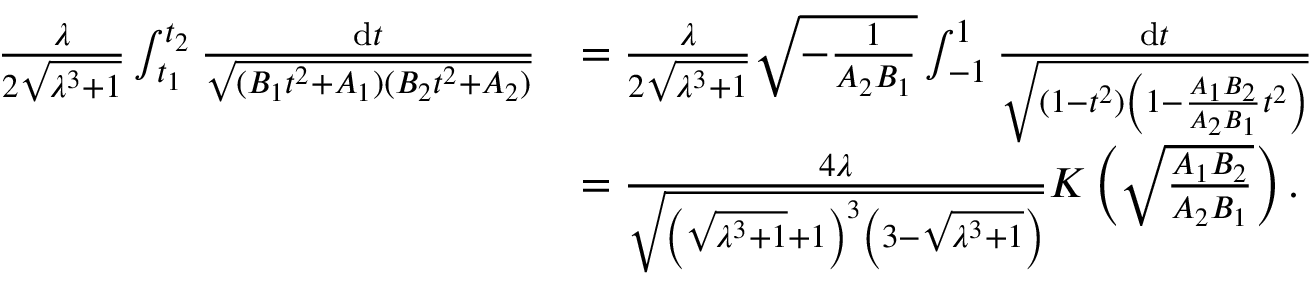Convert formula to latex. <formula><loc_0><loc_0><loc_500><loc_500>\begin{array} { r l } { \frac { \lambda } { 2 \sqrt { \lambda ^ { 3 } + 1 } } \int _ { t _ { 1 } } ^ { t _ { 2 } } \frac { \mathrm d t } { \sqrt { ( B _ { 1 } t ^ { 2 } + A _ { 1 } ) ( B _ { 2 } t ^ { 2 } + A _ { 2 } ) } } } & { = \frac { \lambda } { 2 \sqrt { \lambda ^ { 3 } + 1 } } \sqrt { - \frac { 1 } { A _ { 2 } B _ { 1 } } } \int _ { - 1 } ^ { 1 } \frac { \mathrm d t } { \sqrt { ( 1 - t ^ { 2 } ) \left ( 1 - \frac { A _ { 1 } B _ { 2 } } { A _ { 2 } B _ { 1 } } t ^ { 2 } \right ) } } } \\ & { = \frac { 4 \lambda } { \sqrt { \left ( \sqrt { \lambda ^ { 3 } + 1 } + 1 \right ) ^ { 3 } \left ( 3 - \sqrt { \lambda ^ { 3 } + 1 } \right ) } } K \left ( \sqrt { \frac { A _ { 1 } B _ { 2 } } { A _ { 2 } B _ { 1 } } } \right ) . } \end{array}</formula> 